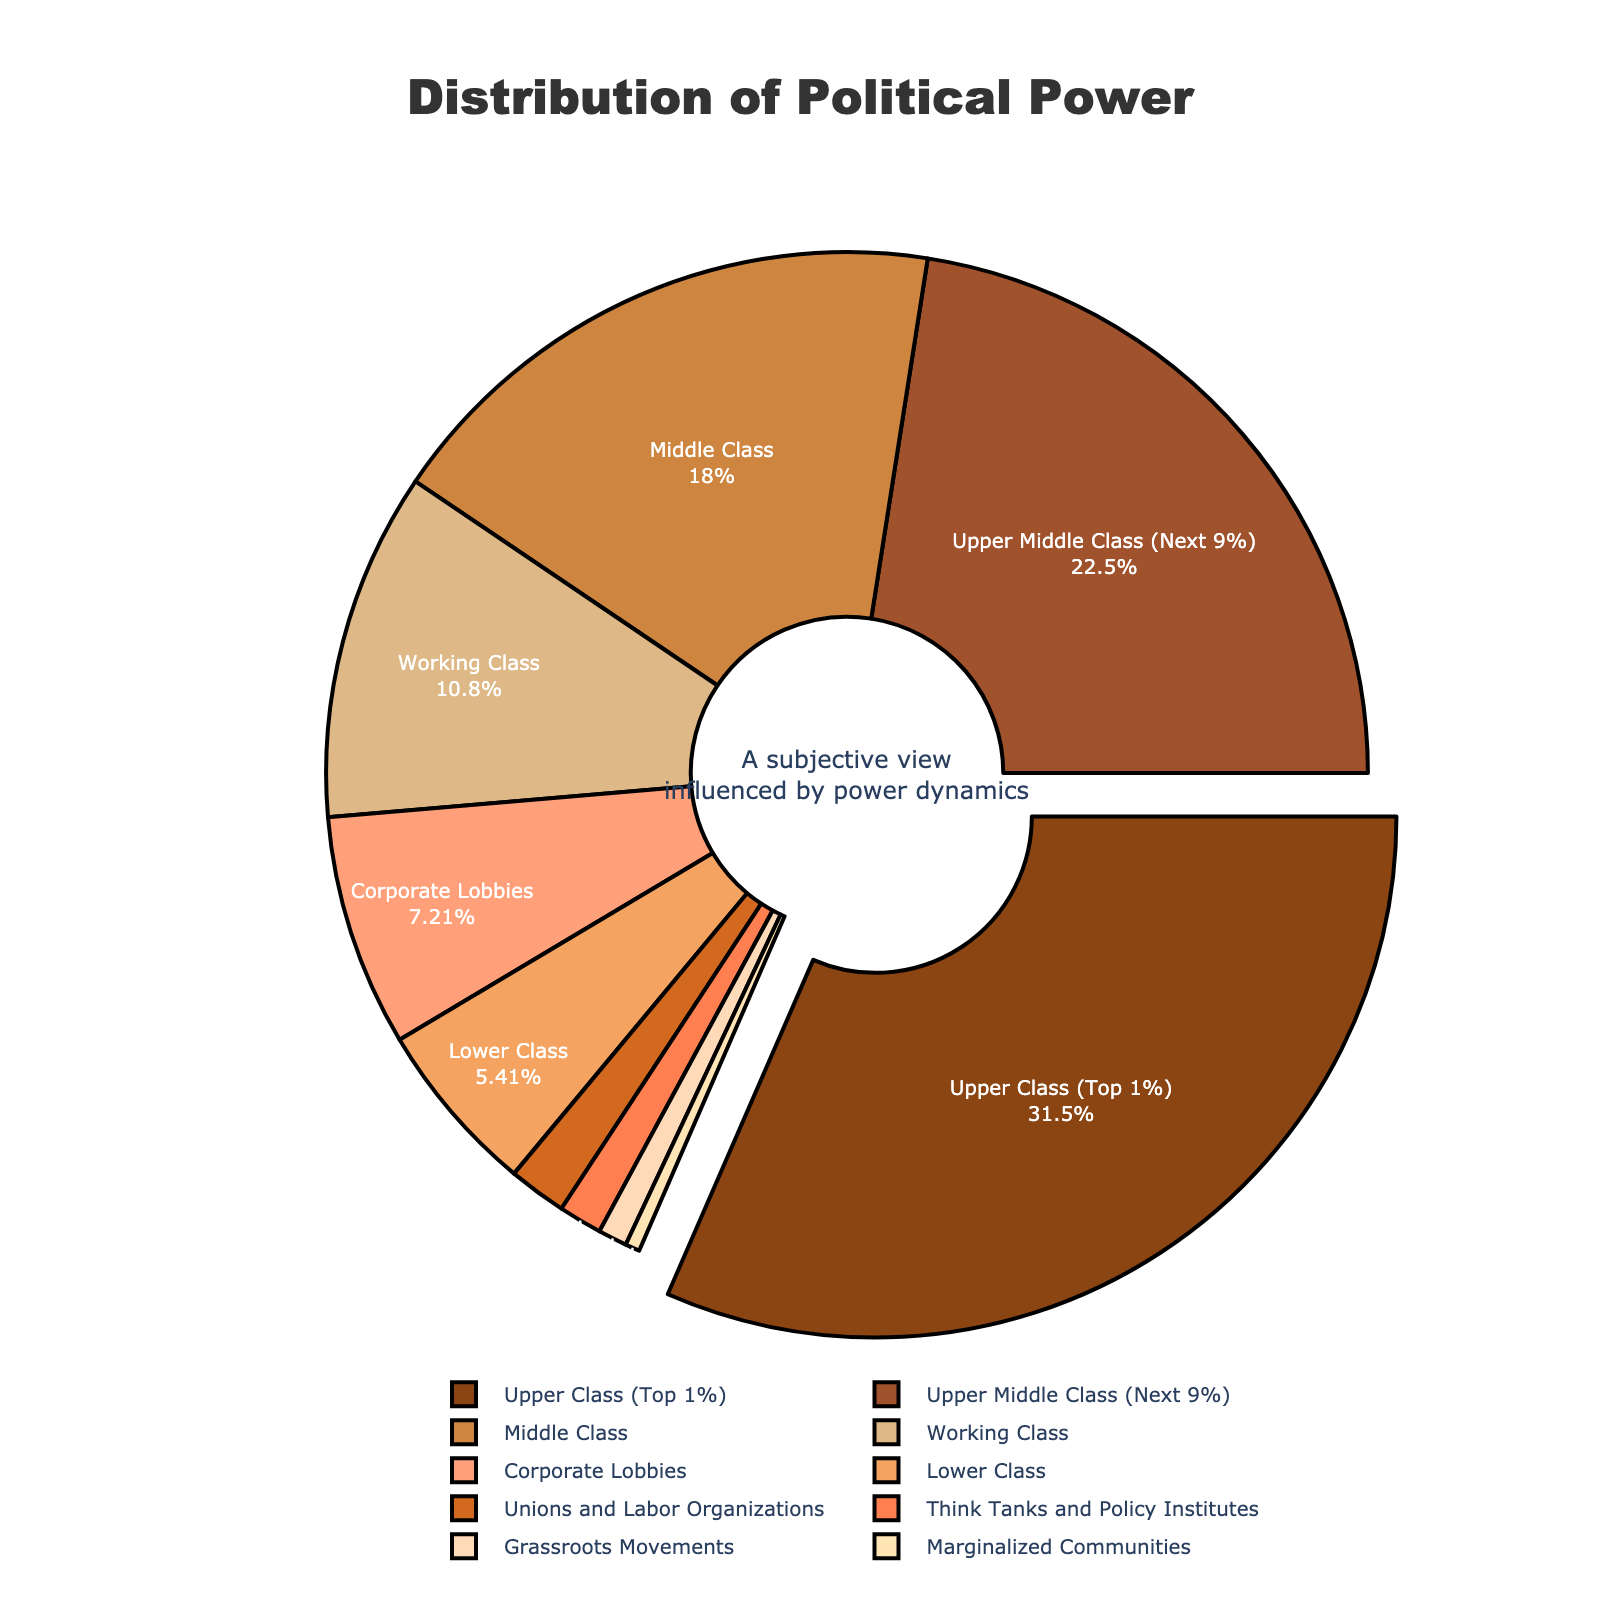What percentage of political power is controlled by economic classes below the Upper Middle Class? To find this, sum the percentages of the Middle Class, Working Class, Lower Class, Unions and Labor Organizations, Grassroots Movements, and Marginalized Communities. The sum is 20 + 12 + 6 + 2 + 1 + 0.5.
Answer: 41.5 Which group has more political power, Corporate Lobbies or the Middle Class? Compare the percentages associated with Corporate Lobbies and the Middle Class. Corporate Lobbies have 8%, and the Middle Class has 20%.
Answer: Middle Class Is the political power of the Working Class greater than all the percentages of Unions and Labor Organizations combined with Grassroots Movements and Marginalized Communities? Sum the percentages of Unions and Labor Organizations, Grassroots Movements, and Marginalized Communities: 2 + 1 + 0.5 = 3.5%. Compare this sum with the Working Class percentage, which is 12%.
Answer: Yes Which group was visually emphasized by being slightly moved outwards from the pie chart? Identify the group that appears to be 'pulled out' or separated slightly from the rest of the pie segments. The Upper Class (Top 1%) is visually emphasized in this way.
Answer: Upper Class (Top 1%) What is the combined political power percentage of Unions and Labor Organizations and Think Tanks and Policy Institutes? Add the percentages of Unions and Labor Organizations and Think Tanks and Policy Institutes: 2 + 1.5.
Answer: 3.5 Which socio-economic class has the second highest political power? The Upper Class (Top 1%) has the highest percentage at 35%. The next highest percentage is 25%, belonging to the Upper Middle Class (Next 9%).
Answer: Upper Middle Class (Next 9%) How does the political power of the Upper Class (Top 1%) compare to the combined power of the Lower Class, Working Class, and Middle Class? Sum the percentages of the Lower Class, Working Class, and Middle Class: 6 + 12 + 20 = 38%. Compare this sum to the Upper Class (Top 1%) percentage, which is 35%.
Answer: Less Identify the groups that jointly account for less than 5% of the total political power. Locate all groups whose percentages individually are less than 5% and add their values to verify they sum to less than 5%. These groups are Grassroots Movements (1%), Marginalized Communities (0.5%), and Think Tanks and Policy Institutes (1.5%), and together they sum to 3%.
Answer: Grassroots Movements, Marginalized Communities, Think Tanks and Policy Institutes 